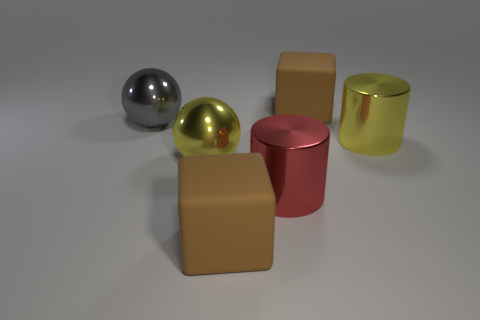There is a cylinder that is in front of the yellow metal cylinder; what material is it?
Provide a succinct answer. Metal. Is the color of the large thing behind the big gray metal ball the same as the big matte thing that is in front of the large red shiny thing?
Make the answer very short. Yes. How many objects are tiny spheres or shiny spheres?
Ensure brevity in your answer.  2. Do the brown object that is behind the large red cylinder and the block that is in front of the large gray metal sphere have the same material?
Provide a short and direct response. Yes. There is a shiny thing that is behind the big yellow ball and in front of the gray shiny thing; what is its shape?
Keep it short and to the point. Cylinder. Is there anything else that has the same material as the large red cylinder?
Provide a short and direct response. Yes. What is the material of the large thing that is both in front of the large yellow metal cylinder and behind the big red shiny object?
Your answer should be very brief. Metal. What shape is the large gray object that is the same material as the big red thing?
Your response must be concise. Sphere. Are there more metal balls that are on the right side of the big gray shiny thing than big blue blocks?
Your answer should be very brief. Yes. What is the large red thing made of?
Provide a short and direct response. Metal. 